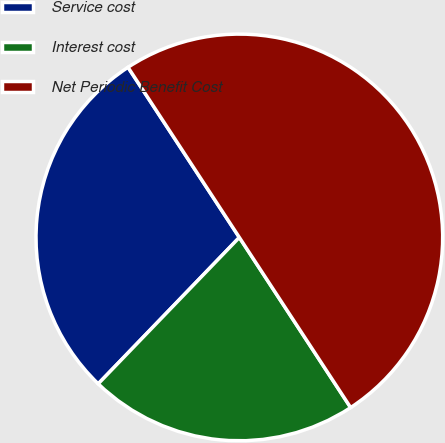Convert chart. <chart><loc_0><loc_0><loc_500><loc_500><pie_chart><fcel>Service cost<fcel>Interest cost<fcel>Net Periodic Benefit Cost<nl><fcel>28.57%<fcel>21.43%<fcel>50.0%<nl></chart> 